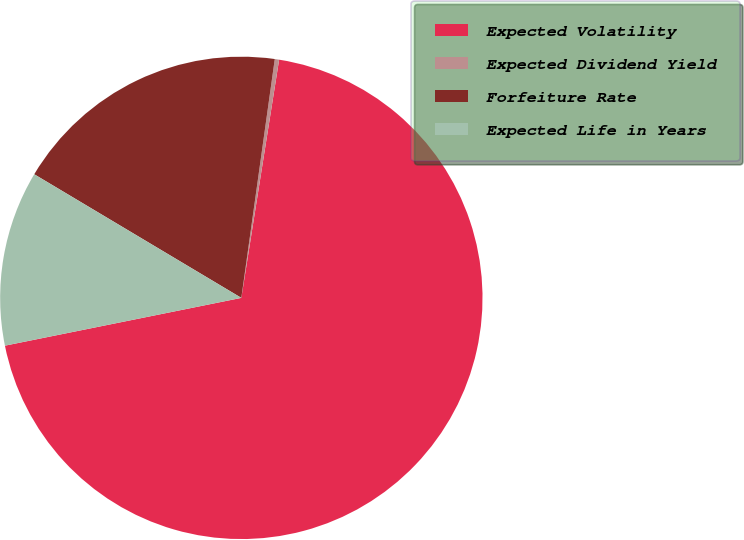<chart> <loc_0><loc_0><loc_500><loc_500><pie_chart><fcel>Expected Volatility<fcel>Expected Dividend Yield<fcel>Forfeiture Rate<fcel>Expected Life in Years<nl><fcel>69.32%<fcel>0.29%<fcel>18.65%<fcel>11.74%<nl></chart> 